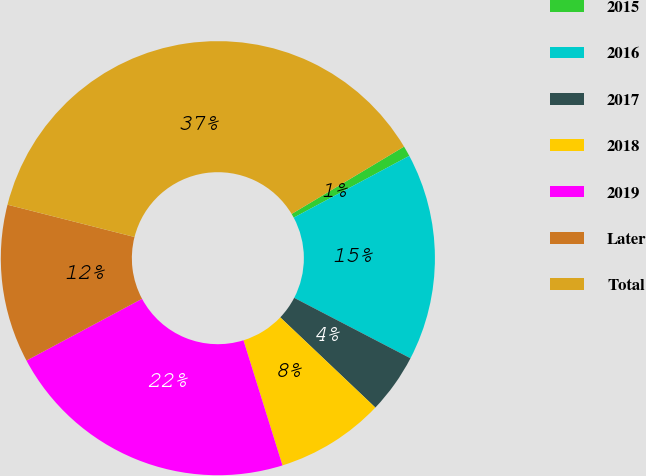Convert chart. <chart><loc_0><loc_0><loc_500><loc_500><pie_chart><fcel>2015<fcel>2016<fcel>2017<fcel>2018<fcel>2019<fcel>Later<fcel>Total<nl><fcel>0.78%<fcel>15.44%<fcel>4.45%<fcel>8.11%<fcel>21.99%<fcel>11.78%<fcel>37.44%<nl></chart> 